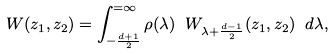Convert formula to latex. <formula><loc_0><loc_0><loc_500><loc_500>W ( z _ { 1 } , z _ { 2 } ) = \int _ { - { \frac { d + 1 } { 2 } } } ^ { = \infty } \rho ( \lambda ) \ W _ { \lambda + \frac { d - 1 } { 2 } } ( z _ { 1 } , z _ { 2 } ) \ d \lambda ,</formula> 